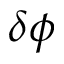<formula> <loc_0><loc_0><loc_500><loc_500>\delta \phi</formula> 